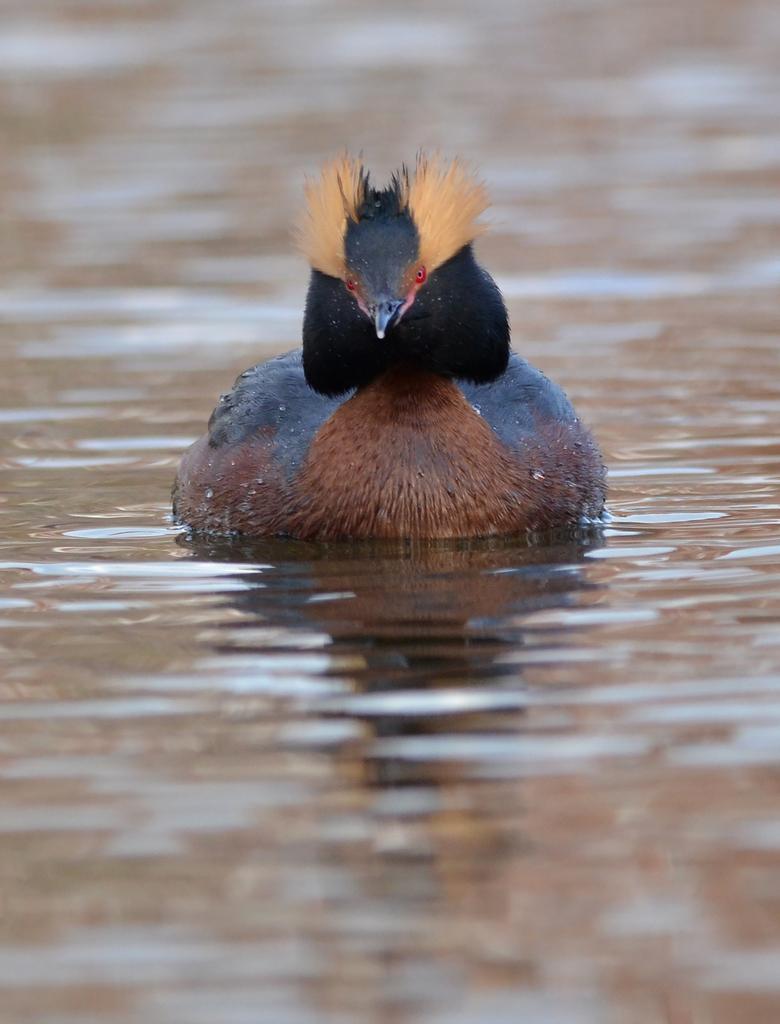Describe this image in one or two sentences. This image is taken outdoors. At the bottom of the image there is a pond with water. In the middle of the image there is a bird in the pond. 